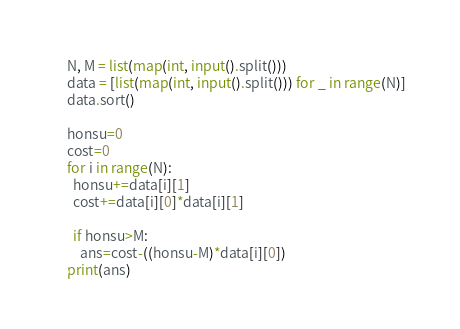<code> <loc_0><loc_0><loc_500><loc_500><_Python_>N, M = list(map(int, input().split()))
data = [list(map(int, input().split())) for _ in range(N)]
data.sort()

honsu=0
cost=0
for i in range(N):
  honsu+=data[i][1]
  cost+=data[i][0]*data[i][1]
 
  if honsu>M:
    ans=cost-((honsu-M)*data[i][0])
print(ans)</code> 